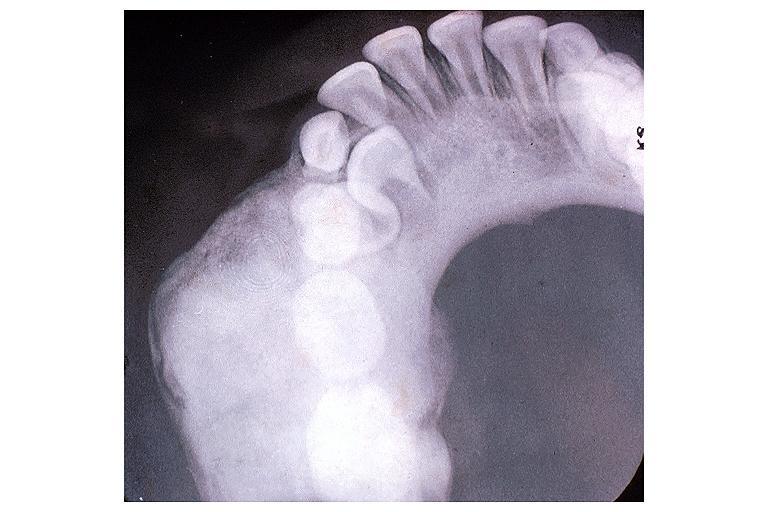s oral present?
Answer the question using a single word or phrase. Yes 